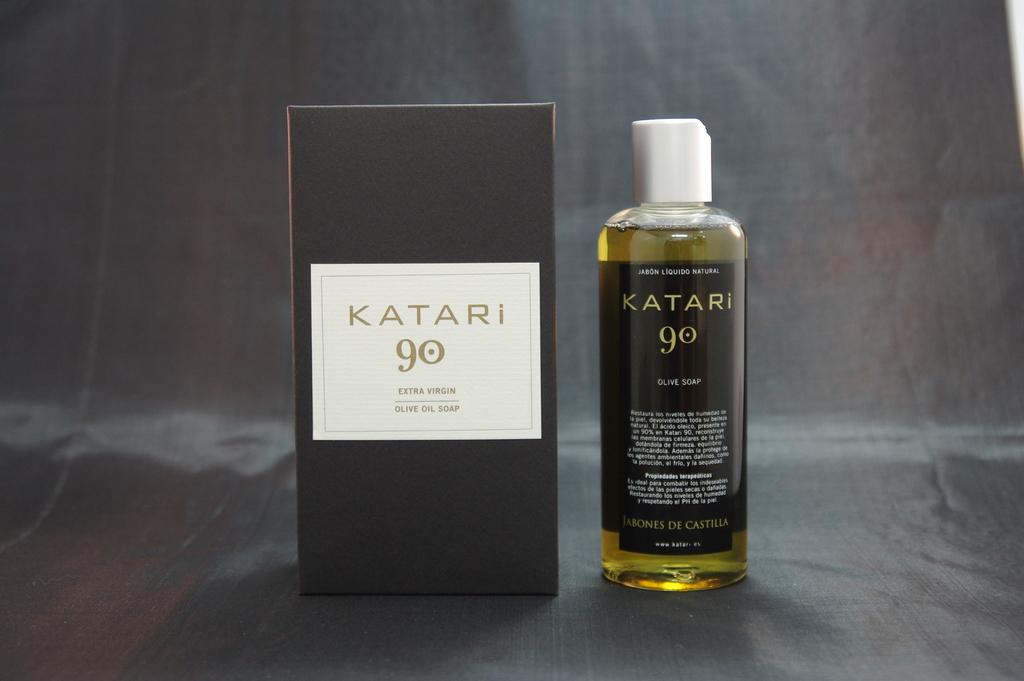What objects can be seen in the image? There is a bottle and a box in the image. Can you describe the bottle in the image? The bottle is one of the objects visible in the image. What other object is present in the image besides the bottle? There is a box in the image. How many fish are swimming in the bottle in the image? There are no fish present in the image, as it only features a bottle and a box. 